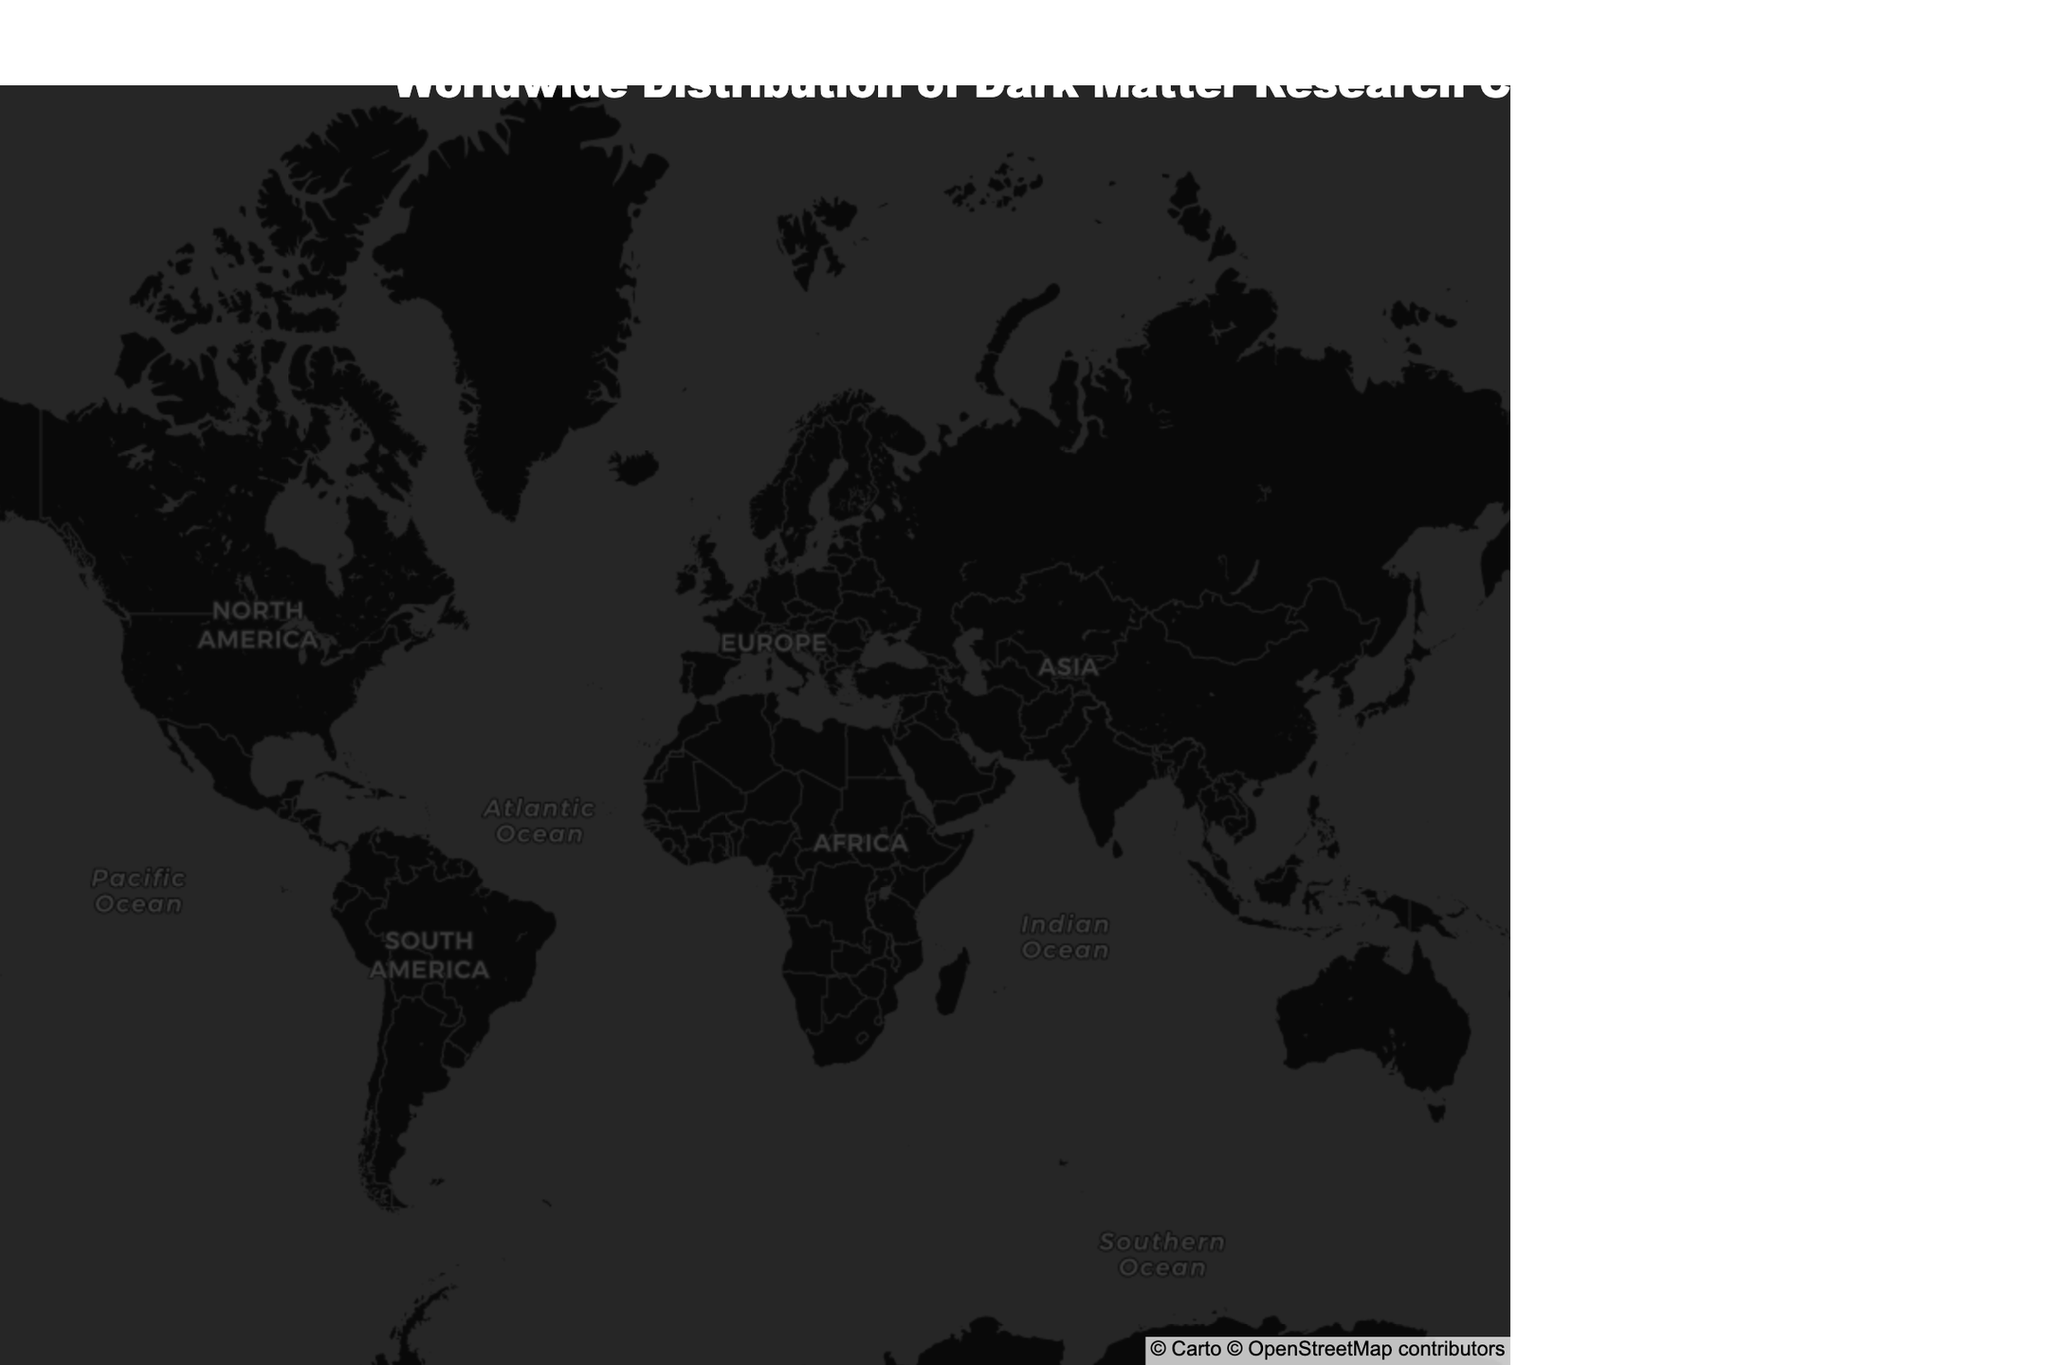What's the title of the figure? The title is displayed prominently at the top of the figure. It summarizes the content and context of the visualized data.
Answer: Worldwide Distribution of Dark Matter Research Centers How many research centers are plotted on the map? Count the number of distinct markers on the map, each representing a research center.
Answer: 11 Which research center specializes in 'Axion dark matter research'? Look for the research center labeled with the specialization 'Axion dark matter research'.
Answer: University of Tokyo Kavli Institute for the Physics and Mathematics of the Universe Which city is the Harvard-Smithsonian Center for Astrophysics located in? Hover over the marker corresponding to the Harvard-Smithsonian Center for Astrophysics to see its details, including the city.
Answer: Boston How many centers are located in the Southern Hemisphere? Identify and count the centers with negative latitude values, as these are located in the Southern Hemisphere.
Answer: 2 Which specialization has the highest representation among the research centers? Count the number of centers for each specialization and determine which has the highest count.
Answer: Each specialization is unique (1 center each) Which center is located closest to the coordinates (47, 8)? Find the center with latitude and longitude closest to 47 and 8 respectively by examining the proximity of the markers to these coordinates.
Answer: University of Zurich Institute for Computational Science Identify the research centers in Europe. Compare the geographic locations of the markers to determine which are in Europe; cross-reference with known European countries.
Answer: University of Zurich Institute for Computational Science, University of Oxford Department of Physics, Institut d'Astrophysique de Paris, Nicolaus Copernicus Astronomical Center, University of Edinburgh Institute for Astronomy What is the latitude and longitude of the Australian National University Mount Stromlo Observatory? Hover over the marker for the Australian National University Mount Stromlo Observatory to see its latitude and longitude details.
Answer: Latitude: -35.2809, Longitude: 149.1300 List the specializations related to dark matter particle detection. Locate and list the centers whose specializations include particle detection by examining hover texts for relevance to particle detection.
Answer: Dark matter particle detection, Dark matter direct detection experiments 